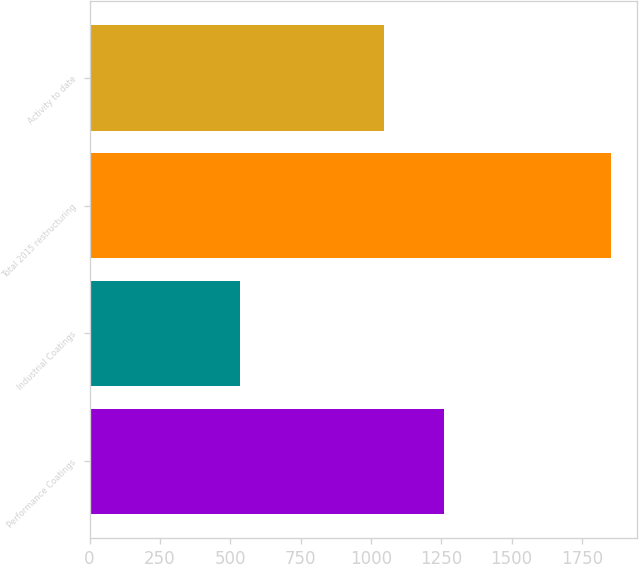Convert chart. <chart><loc_0><loc_0><loc_500><loc_500><bar_chart><fcel>Performance Coatings<fcel>Industrial Coatings<fcel>Total 2015 restructuring<fcel>Activity to date<nl><fcel>1259<fcel>534<fcel>1853<fcel>1047<nl></chart> 